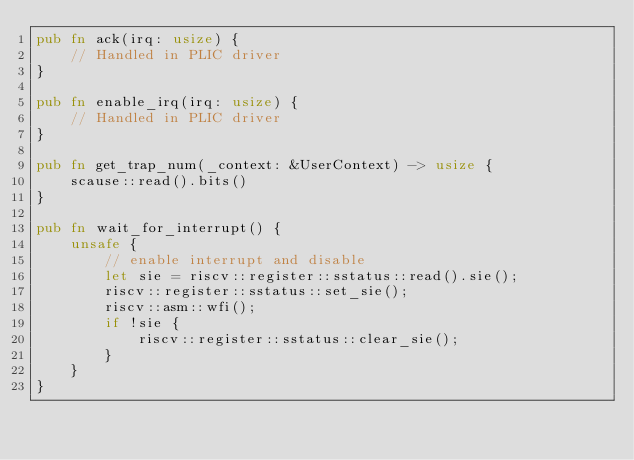<code> <loc_0><loc_0><loc_500><loc_500><_Rust_>pub fn ack(irq: usize) {
    // Handled in PLIC driver
}

pub fn enable_irq(irq: usize) {
    // Handled in PLIC driver
}

pub fn get_trap_num(_context: &UserContext) -> usize {
    scause::read().bits()
}

pub fn wait_for_interrupt() {
    unsafe {
        // enable interrupt and disable
        let sie = riscv::register::sstatus::read().sie();
        riscv::register::sstatus::set_sie();
        riscv::asm::wfi();
        if !sie {
            riscv::register::sstatus::clear_sie();
        }
    }
}
</code> 